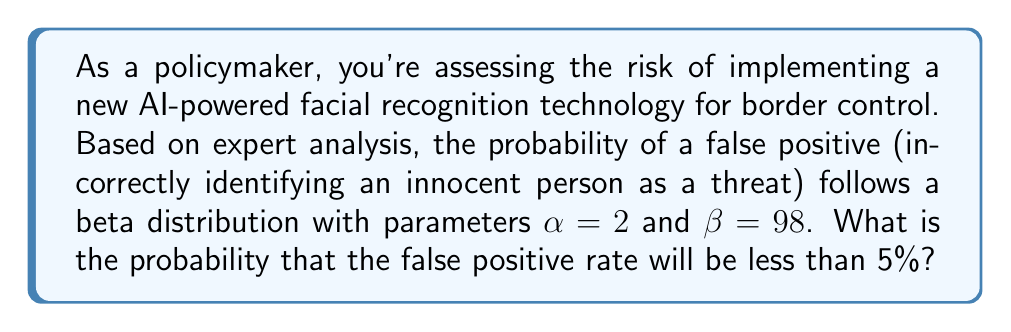Help me with this question. To solve this problem, we need to use the cumulative distribution function (CDF) of the beta distribution. The steps are as follows:

1) The beta distribution with parameters $\alpha$ and $\beta$ has a CDF given by:

   $$F(x; \alpha, \beta) = \frac{B(x; \alpha, \beta)}{B(\alpha, \beta)}$$

   where $B(x; \alpha, \beta)$ is the incomplete beta function and $B(\alpha, \beta)$ is the beta function.

2) In this case, we want to find $P(X < 0.05)$ where $X \sim Beta(2, 98)$.

3) This probability is equal to $F(0.05; 2, 98)$.

4) Calculating this exactly involves complex integration. In practice, we would use statistical software or tables. However, we can approximate it using the following facts about the beta distribution:

   - The mean of a beta distribution is $\frac{\alpha}{\alpha + \beta} = \frac{2}{100} = 0.02$
   - The variance is $\frac{\alpha\beta}{(\alpha+\beta)^2(\alpha+\beta+1)} \approx 0.0002$

5) Given these parameters, we can see that 0.05 is about 2 standard deviations (√0.0002 ≈ 0.014) above the mean.

6) Using the empirical rule (68-95-99.7 rule), we know that approximately 97.5% of the distribution lies below 2 standard deviations above the mean.

Therefore, we can estimate that the probability of the false positive rate being less than 5% is approximately 0.975 or 97.5%.
Answer: $\approx 0.975$ 